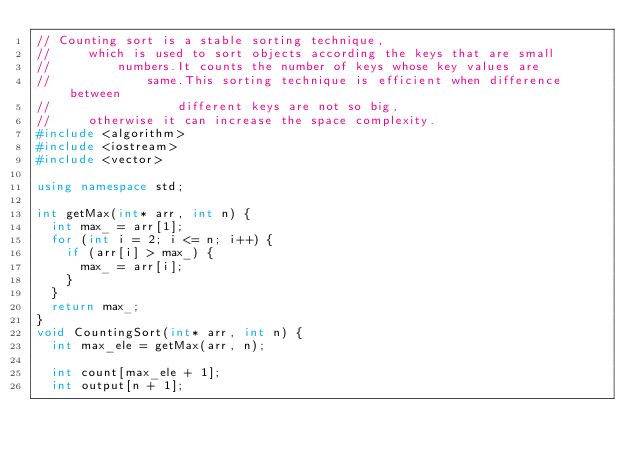Convert code to text. <code><loc_0><loc_0><loc_500><loc_500><_C++_>// Counting sort is a stable sorting technique,
//     which is used to sort objects according the keys that are small
//         numbers.It counts the number of keys whose key values are
//             same.This sorting technique is efficient when difference between
//                 different keys are not so big,
//     otherwise it can increase the space complexity.
#include <algorithm>
#include <iostream>
#include <vector>

using namespace std;

int getMax(int* arr, int n) {
  int max_ = arr[1];
  for (int i = 2; i <= n; i++) {
    if (arr[i] > max_) {
      max_ = arr[i];
    }
  }
  return max_;
}
void CountingSort(int* arr, int n) {
  int max_ele = getMax(arr, n);

  int count[max_ele + 1];
  int output[n + 1];
</code> 